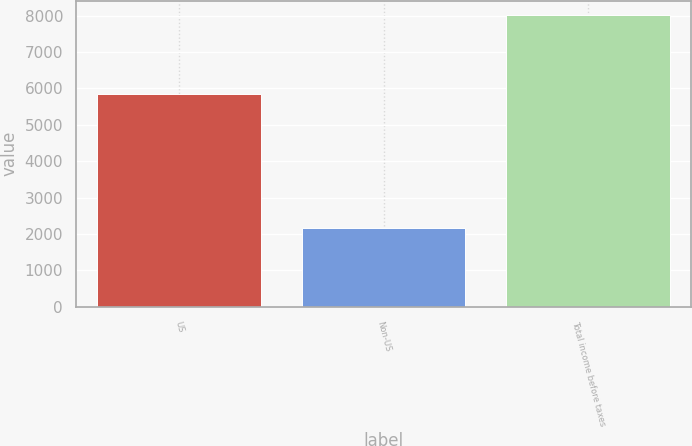Convert chart. <chart><loc_0><loc_0><loc_500><loc_500><bar_chart><fcel>US<fcel>Non-US<fcel>Total income before taxes<nl><fcel>5839<fcel>2173<fcel>8012<nl></chart> 